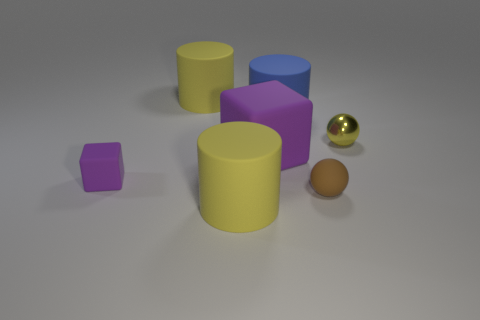Is there any other thing that is the same material as the tiny yellow sphere?
Give a very brief answer. No. Are there more small metallic balls right of the small purple thing than large matte cylinders right of the brown rubber ball?
Offer a terse response. Yes. How many other things are there of the same shape as the blue object?
Your answer should be very brief. 2. Are there any cylinders that are behind the big purple block that is right of the small rubber block?
Your answer should be compact. Yes. What number of big cylinders are there?
Offer a terse response. 3. Does the tiny cube have the same color as the block that is to the right of the small block?
Keep it short and to the point. Yes. Is the number of tiny cyan shiny balls greater than the number of big purple rubber things?
Give a very brief answer. No. Is there anything else that is the same color as the matte sphere?
Provide a succinct answer. No. How many other objects are there of the same size as the rubber sphere?
Offer a very short reply. 2. There is a large yellow thing that is in front of the yellow rubber thing that is behind the matte cylinder in front of the big blue thing; what is its material?
Keep it short and to the point. Rubber. 